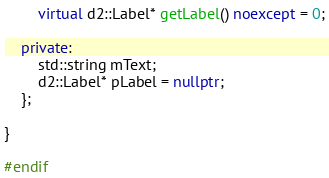Convert code to text. <code><loc_0><loc_0><loc_500><loc_500><_C++_>        virtual d2::Label* getLabel() noexcept = 0;

    private:
        std::string mText;
        d2::Label* pLabel = nullptr;
    };

}

#endif</code> 